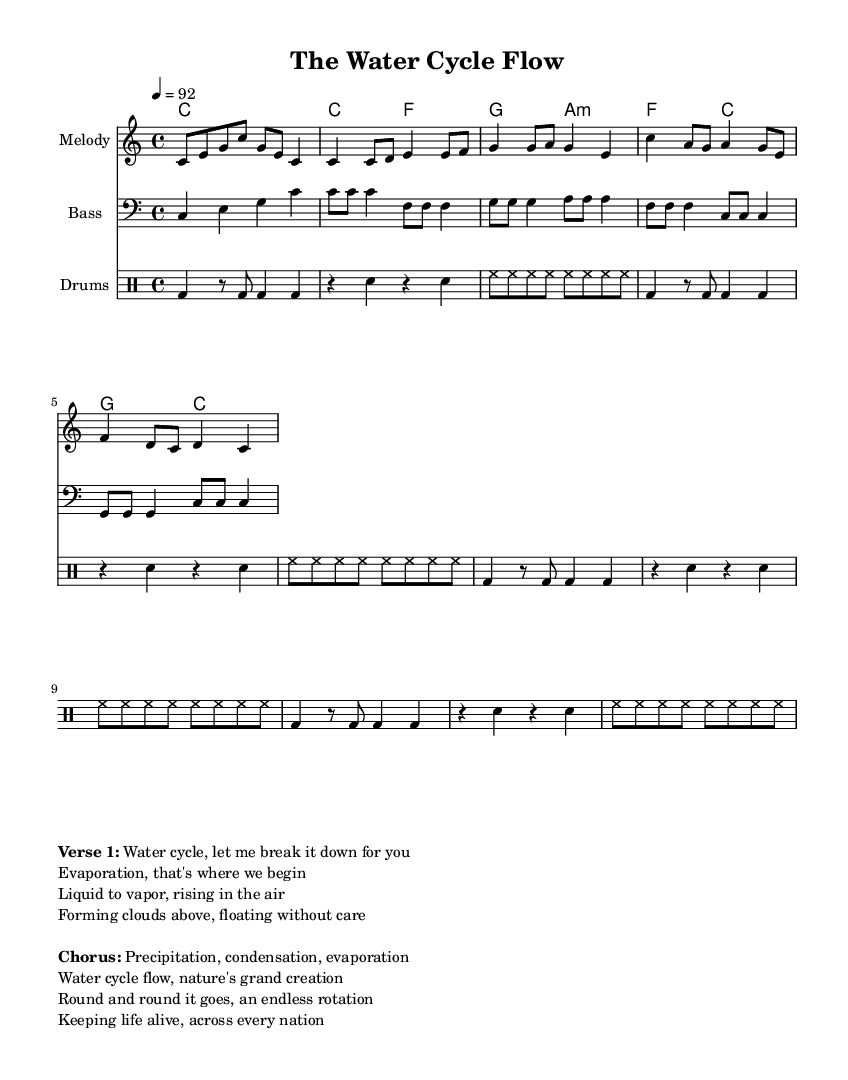What is the key signature of this music? The key signature indicated at the beginning of the score is C major, which consists of no sharps or flats. You can identify the key signature usually located between the clef and the time signature at the start of the music.
Answer: C major What is the time signature of this music? The time signature is found next to the key signature and indicates how many beats are in each measure. In this case, the time signature is 4/4, meaning there are four beats per measure.
Answer: 4/4 What is the tempo marking in this music? The tempo marking is specified above the staff, showing the tempo at which the piece should be played. Here, it is marked as quarter note equals 92 beats per minute.
Answer: 92 How many measures are in the verse section? To find the number of measures in the verse section, one can count the individual measures represented in the melody staff for that section. The verse contains four measures.
Answer: 4 What rhythmic pattern is used in the drums? The drumming section employs a repeating rhythmic pattern made up of bass drum, snare drum, and hi-hat symbols in a regular sequence. This can be analyzed by observing the drum line's organization to identify the repeating rhythm. The rhythm pattern comprises a combination of bass and snare according to the specified repetition.
Answer: Repeated pattern What is the main theme presented in the chorus? The chorus combines key phrases about the water cycle such as precipitation, condensation, and evaporation. This entails a deeper understanding of the lyrics that highlight the essential elements of the water cycle in nature. The phrase focuses on the cyclical nature of water and its importance in sustaining life.
Answer: Water cycle What is the dominant instrument for the melody? The melody in this score is shown on the staff with a specific instrument name, which clearly indicates the main voice. In this case, the melody is primarily played by the "Melody" instrument, which would typically refer to a lead instrument or vocal line in rap.
Answer: Melody 